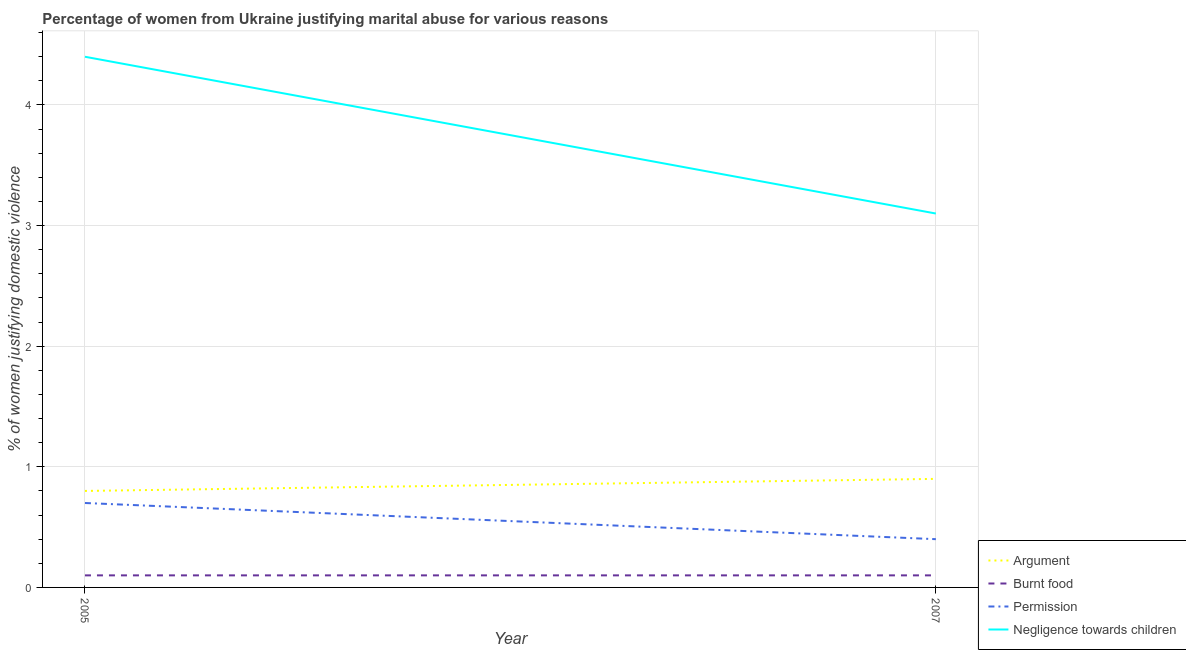How many different coloured lines are there?
Make the answer very short. 4. Across all years, what is the maximum percentage of women justifying abuse for burning food?
Provide a succinct answer. 0.1. In which year was the percentage of women justifying abuse in the case of an argument maximum?
Provide a succinct answer. 2007. In which year was the percentage of women justifying abuse for going without permission minimum?
Offer a very short reply. 2007. What is the total percentage of women justifying abuse in the case of an argument in the graph?
Offer a terse response. 1.7. What is the difference between the percentage of women justifying abuse in the case of an argument in 2005 and that in 2007?
Give a very brief answer. -0.1. What is the average percentage of women justifying abuse for showing negligence towards children per year?
Offer a very short reply. 3.75. In the year 2005, what is the difference between the percentage of women justifying abuse for burning food and percentage of women justifying abuse for going without permission?
Offer a terse response. -0.6. In how many years, is the percentage of women justifying abuse for going without permission greater than 1 %?
Your answer should be very brief. 0. What is the ratio of the percentage of women justifying abuse for burning food in 2005 to that in 2007?
Offer a terse response. 1. Is it the case that in every year, the sum of the percentage of women justifying abuse in the case of an argument and percentage of women justifying abuse for burning food is greater than the sum of percentage of women justifying abuse for going without permission and percentage of women justifying abuse for showing negligence towards children?
Provide a succinct answer. No. Is it the case that in every year, the sum of the percentage of women justifying abuse in the case of an argument and percentage of women justifying abuse for burning food is greater than the percentage of women justifying abuse for going without permission?
Provide a succinct answer. Yes. Is the percentage of women justifying abuse in the case of an argument strictly greater than the percentage of women justifying abuse for burning food over the years?
Make the answer very short. Yes. How many years are there in the graph?
Your answer should be compact. 2. How many legend labels are there?
Provide a short and direct response. 4. What is the title of the graph?
Give a very brief answer. Percentage of women from Ukraine justifying marital abuse for various reasons. Does "Ease of arranging shipments" appear as one of the legend labels in the graph?
Offer a very short reply. No. What is the label or title of the Y-axis?
Ensure brevity in your answer.  % of women justifying domestic violence. What is the % of women justifying domestic violence of Negligence towards children in 2005?
Keep it short and to the point. 4.4. What is the % of women justifying domestic violence in Argument in 2007?
Your response must be concise. 0.9. Across all years, what is the maximum % of women justifying domestic violence of Argument?
Ensure brevity in your answer.  0.9. Across all years, what is the maximum % of women justifying domestic violence in Burnt food?
Offer a very short reply. 0.1. Across all years, what is the maximum % of women justifying domestic violence in Permission?
Make the answer very short. 0.7. Across all years, what is the maximum % of women justifying domestic violence of Negligence towards children?
Your answer should be very brief. 4.4. Across all years, what is the minimum % of women justifying domestic violence in Argument?
Offer a very short reply. 0.8. What is the total % of women justifying domestic violence in Argument in the graph?
Your answer should be compact. 1.7. What is the total % of women justifying domestic violence in Permission in the graph?
Provide a succinct answer. 1.1. What is the total % of women justifying domestic violence of Negligence towards children in the graph?
Provide a short and direct response. 7.5. What is the difference between the % of women justifying domestic violence in Burnt food in 2005 and that in 2007?
Ensure brevity in your answer.  0. What is the difference between the % of women justifying domestic violence in Permission in 2005 and that in 2007?
Your answer should be compact. 0.3. What is the difference between the % of women justifying domestic violence in Negligence towards children in 2005 and that in 2007?
Offer a terse response. 1.3. What is the difference between the % of women justifying domestic violence in Argument in 2005 and the % of women justifying domestic violence in Burnt food in 2007?
Provide a succinct answer. 0.7. What is the difference between the % of women justifying domestic violence in Argument in 2005 and the % of women justifying domestic violence in Negligence towards children in 2007?
Make the answer very short. -2.3. What is the difference between the % of women justifying domestic violence of Burnt food in 2005 and the % of women justifying domestic violence of Permission in 2007?
Give a very brief answer. -0.3. What is the difference between the % of women justifying domestic violence of Permission in 2005 and the % of women justifying domestic violence of Negligence towards children in 2007?
Keep it short and to the point. -2.4. What is the average % of women justifying domestic violence of Argument per year?
Give a very brief answer. 0.85. What is the average % of women justifying domestic violence in Burnt food per year?
Offer a very short reply. 0.1. What is the average % of women justifying domestic violence of Permission per year?
Your answer should be very brief. 0.55. What is the average % of women justifying domestic violence in Negligence towards children per year?
Your response must be concise. 3.75. In the year 2005, what is the difference between the % of women justifying domestic violence of Argument and % of women justifying domestic violence of Burnt food?
Your response must be concise. 0.7. In the year 2005, what is the difference between the % of women justifying domestic violence in Argument and % of women justifying domestic violence in Permission?
Ensure brevity in your answer.  0.1. In the year 2005, what is the difference between the % of women justifying domestic violence in Argument and % of women justifying domestic violence in Negligence towards children?
Offer a terse response. -3.6. In the year 2005, what is the difference between the % of women justifying domestic violence of Permission and % of women justifying domestic violence of Negligence towards children?
Make the answer very short. -3.7. In the year 2007, what is the difference between the % of women justifying domestic violence of Argument and % of women justifying domestic violence of Burnt food?
Give a very brief answer. 0.8. In the year 2007, what is the difference between the % of women justifying domestic violence of Argument and % of women justifying domestic violence of Permission?
Offer a terse response. 0.5. In the year 2007, what is the difference between the % of women justifying domestic violence in Argument and % of women justifying domestic violence in Negligence towards children?
Offer a terse response. -2.2. What is the ratio of the % of women justifying domestic violence of Burnt food in 2005 to that in 2007?
Your answer should be compact. 1. What is the ratio of the % of women justifying domestic violence of Negligence towards children in 2005 to that in 2007?
Offer a terse response. 1.42. What is the difference between the highest and the second highest % of women justifying domestic violence of Argument?
Your answer should be compact. 0.1. What is the difference between the highest and the second highest % of women justifying domestic violence of Negligence towards children?
Provide a succinct answer. 1.3. What is the difference between the highest and the lowest % of women justifying domestic violence in Burnt food?
Your response must be concise. 0. 